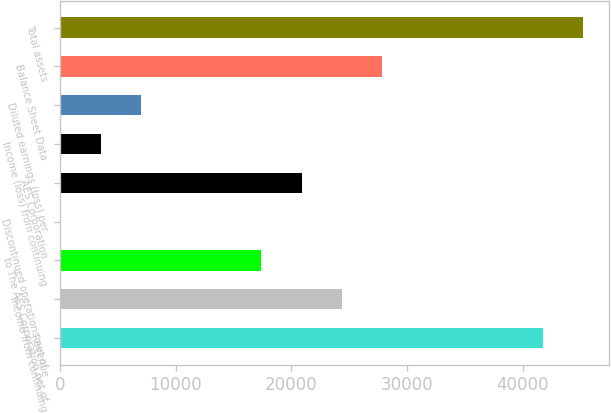<chart> <loc_0><loc_0><loc_500><loc_500><bar_chart><fcel>Revenue<fcel>Income from continuing<fcel>to The AES Corporation net of<fcel>Discontinued operations net of<fcel>AES Corporation<fcel>Income (loss) from continuing<fcel>Diluted earnings (loss) per<fcel>Balance Sheet Data<fcel>Total assets<nl><fcel>41767.2<fcel>24364.2<fcel>17403<fcel>0.09<fcel>20883.6<fcel>3480.68<fcel>6961.27<fcel>27844.8<fcel>45247.8<nl></chart> 